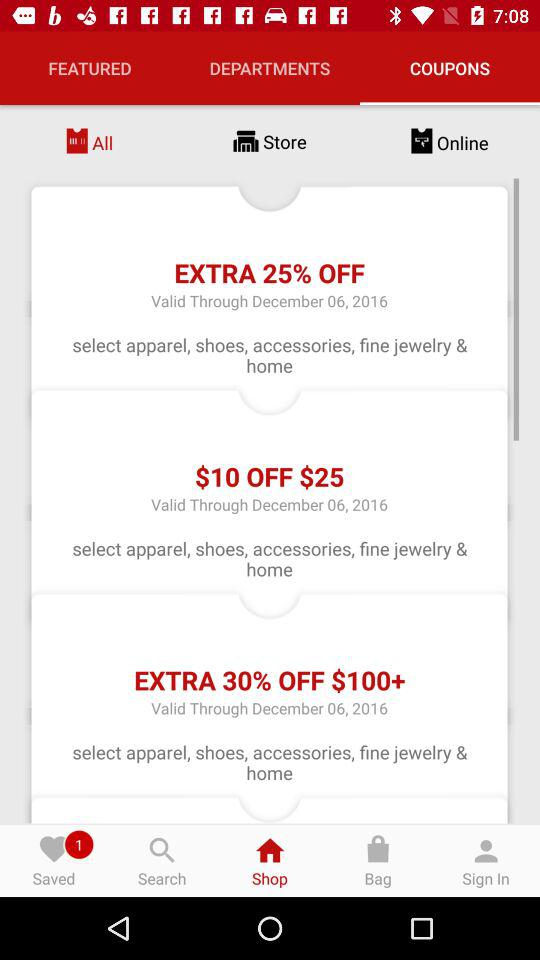How many coupons have a discount greater than $10?
Answer the question using a single word or phrase. 2 